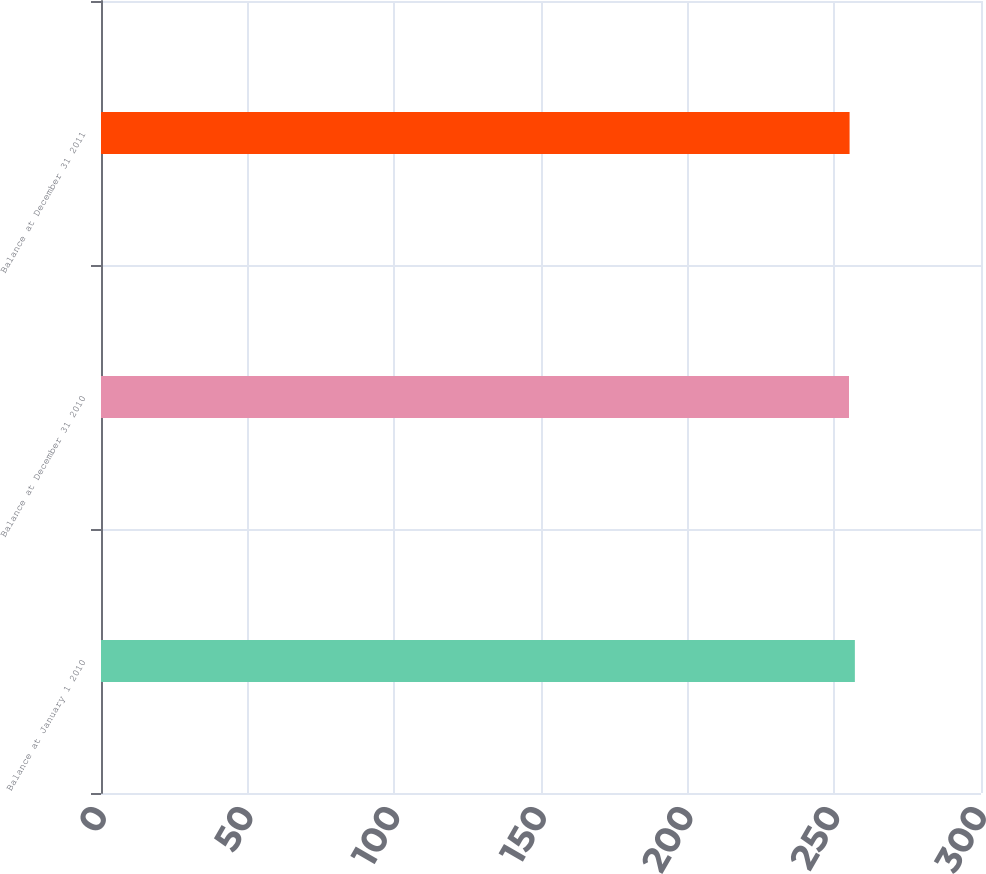Convert chart to OTSL. <chart><loc_0><loc_0><loc_500><loc_500><bar_chart><fcel>Balance at January 1 2010<fcel>Balance at December 31 2010<fcel>Balance at December 31 2011<nl><fcel>257<fcel>255<fcel>255.2<nl></chart> 